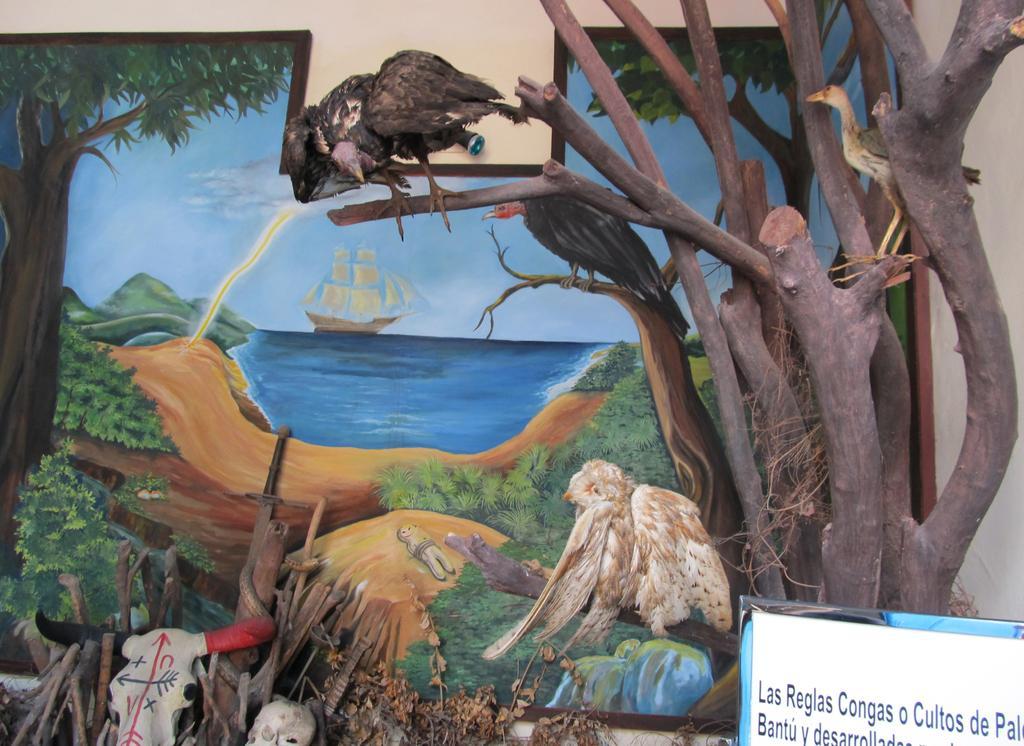Can you describe this image briefly? In this image I can see the branches of the tree to the right. I can see few boards on the branches. In the back there is a board. On the board I can see the water. To the side of the water there are trees and I can see the boat on the water. In the back there is a blue sky. And the board is attached to the wall. To the right I can see another board and something is written on it. 